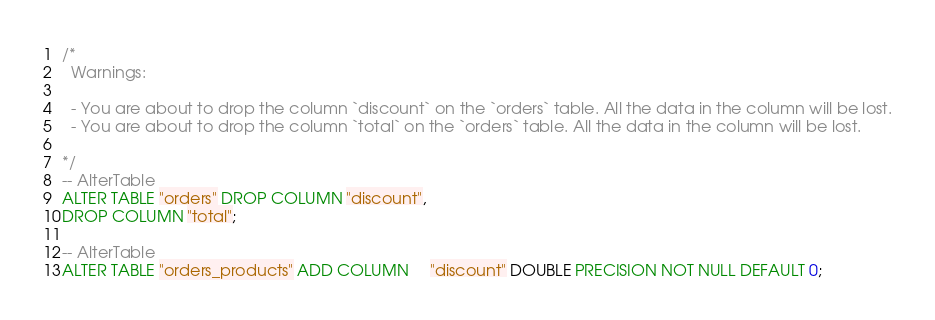Convert code to text. <code><loc_0><loc_0><loc_500><loc_500><_SQL_>/*
  Warnings:

  - You are about to drop the column `discount` on the `orders` table. All the data in the column will be lost.
  - You are about to drop the column `total` on the `orders` table. All the data in the column will be lost.

*/
-- AlterTable
ALTER TABLE "orders" DROP COLUMN "discount",
DROP COLUMN "total";

-- AlterTable
ALTER TABLE "orders_products" ADD COLUMN     "discount" DOUBLE PRECISION NOT NULL DEFAULT 0;
</code> 